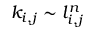Convert formula to latex. <formula><loc_0><loc_0><loc_500><loc_500>k _ { i , j } \sim l _ { i , j } ^ { n }</formula> 